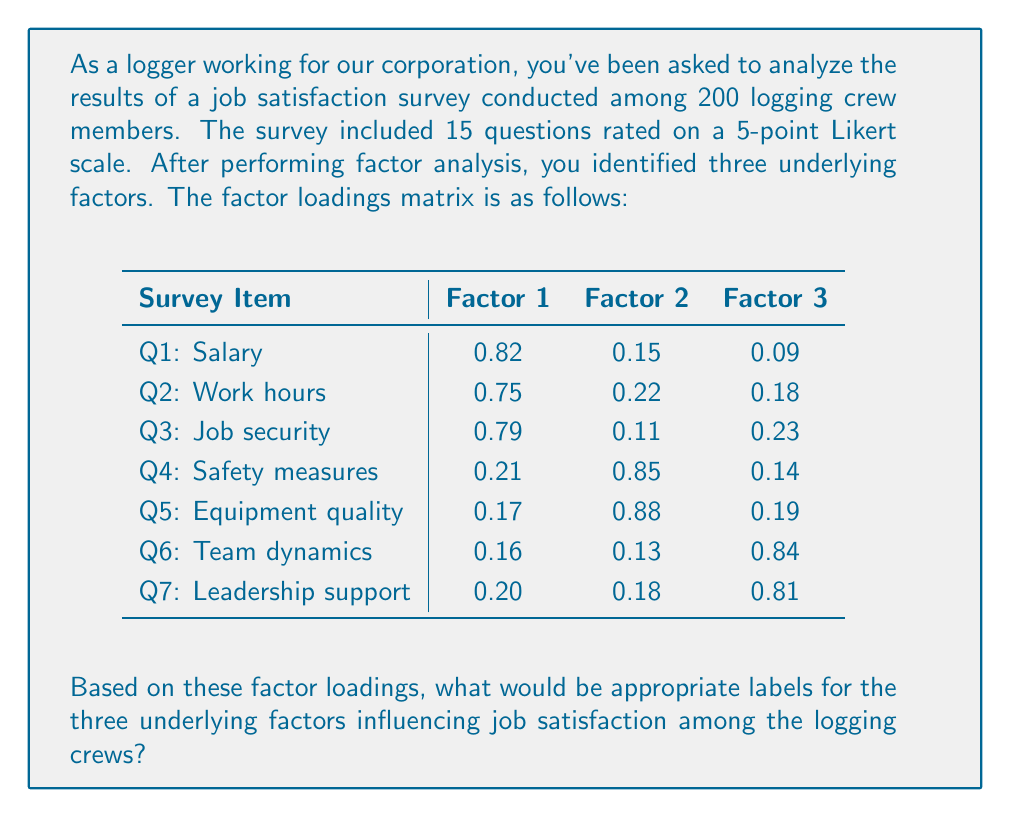Teach me how to tackle this problem. To determine appropriate labels for the underlying factors, we need to examine the factor loadings and identify which survey items load heavily on each factor. We'll consider loadings above 0.5 as significant.

Step 1: Analyze Factor 1
- Q1 (Salary): 0.82
- Q2 (Work hours): 0.75
- Q3 (Job security): 0.79

These items all relate to job conditions and compensation. An appropriate label for Factor 1 could be "Compensation and Job Stability."

Step 2: Analyze Factor 2
- Q4 (Safety measures): 0.85
- Q5 (Equipment quality): 0.88

These items relate to the physical working conditions and safety. An appropriate label for Factor 2 could be "Workplace Safety and Equipment."

Step 3: Analyze Factor 3
- Q6 (Team dynamics): 0.84
- Q7 (Leadership support): 0.81

These items relate to interpersonal relationships and support within the work environment. An appropriate label for Factor 3 could be "Work Relationships and Support."

Step 4: Summarize the factors
1. Compensation and Job Stability
2. Workplace Safety and Equipment
3. Work Relationships and Support

These three factors represent the underlying dimensions influencing job satisfaction among the logging crews, based on the factor analysis results.
Answer: 1. Compensation and Job Stability
2. Workplace Safety and Equipment
3. Work Relationships and Support 